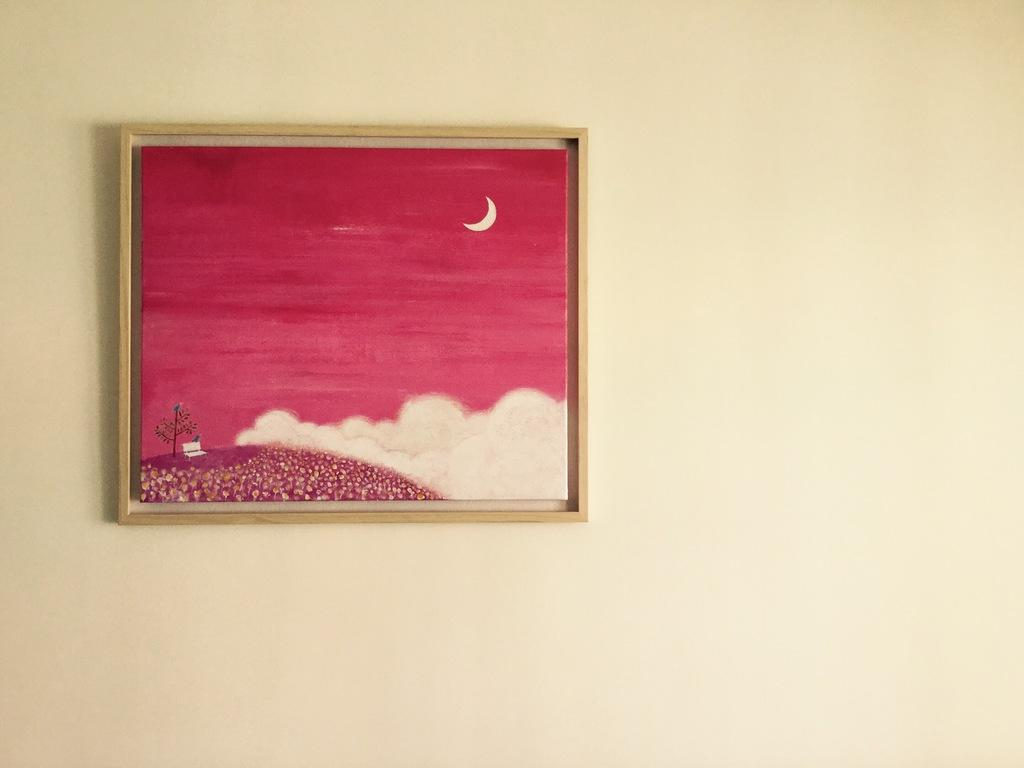What is the main object in the image? The main object in the image is a photo frame. How is the photo frame positioned in the image? The photo frame is attached to the wall. What is the appearance of the photo frame? The photo frame resembles a painting. Can you tell me how many boys are wearing apparel in the photo frame? There are no boys or apparel visible in the photo frame; it resembles a painting. What type of train can be seen passing by in the background of the photo frame? There is no train visible in the background of the photo frame; it resembles a painting. 